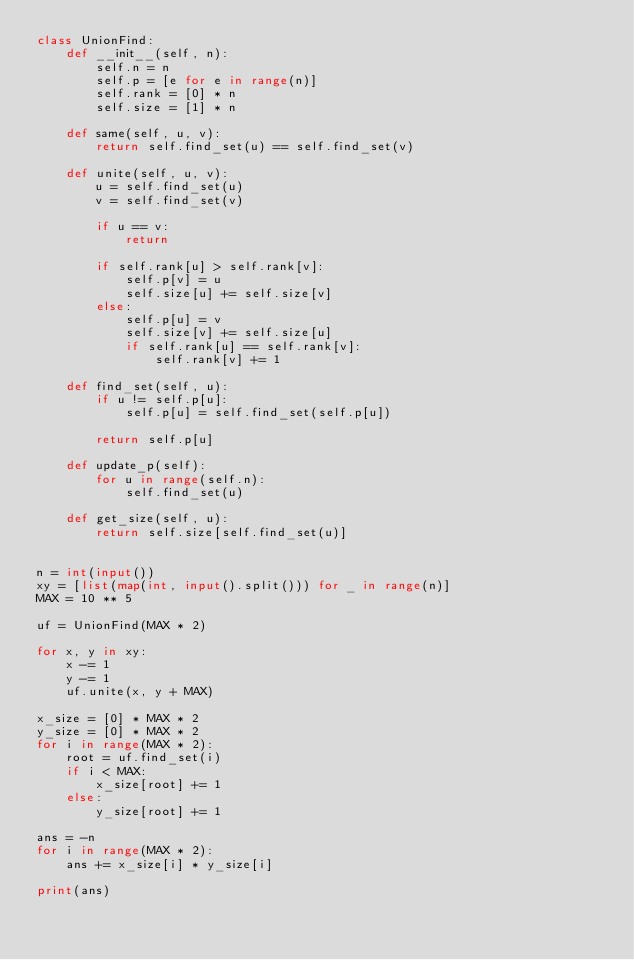Convert code to text. <code><loc_0><loc_0><loc_500><loc_500><_Python_>class UnionFind:
    def __init__(self, n):
        self.n = n
        self.p = [e for e in range(n)]
        self.rank = [0] * n
        self.size = [1] * n

    def same(self, u, v):
        return self.find_set(u) == self.find_set(v)

    def unite(self, u, v):
        u = self.find_set(u)
        v = self.find_set(v)

        if u == v:
            return

        if self.rank[u] > self.rank[v]:
            self.p[v] = u
            self.size[u] += self.size[v]
        else:
            self.p[u] = v
            self.size[v] += self.size[u]
            if self.rank[u] == self.rank[v]:
                self.rank[v] += 1

    def find_set(self, u):
        if u != self.p[u]:
            self.p[u] = self.find_set(self.p[u])

        return self.p[u]

    def update_p(self):
        for u in range(self.n):
            self.find_set(u)

    def get_size(self, u):
        return self.size[self.find_set(u)]


n = int(input())
xy = [list(map(int, input().split())) for _ in range(n)]
MAX = 10 ** 5

uf = UnionFind(MAX * 2)

for x, y in xy:
    x -= 1
    y -= 1
    uf.unite(x, y + MAX)

x_size = [0] * MAX * 2
y_size = [0] * MAX * 2
for i in range(MAX * 2):
    root = uf.find_set(i)
    if i < MAX:
        x_size[root] += 1
    else:
        y_size[root] += 1

ans = -n
for i in range(MAX * 2):
    ans += x_size[i] * y_size[i]

print(ans)
</code> 